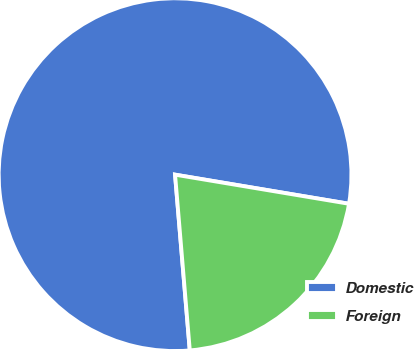Convert chart. <chart><loc_0><loc_0><loc_500><loc_500><pie_chart><fcel>Domestic<fcel>Foreign<nl><fcel>78.97%<fcel>21.03%<nl></chart> 